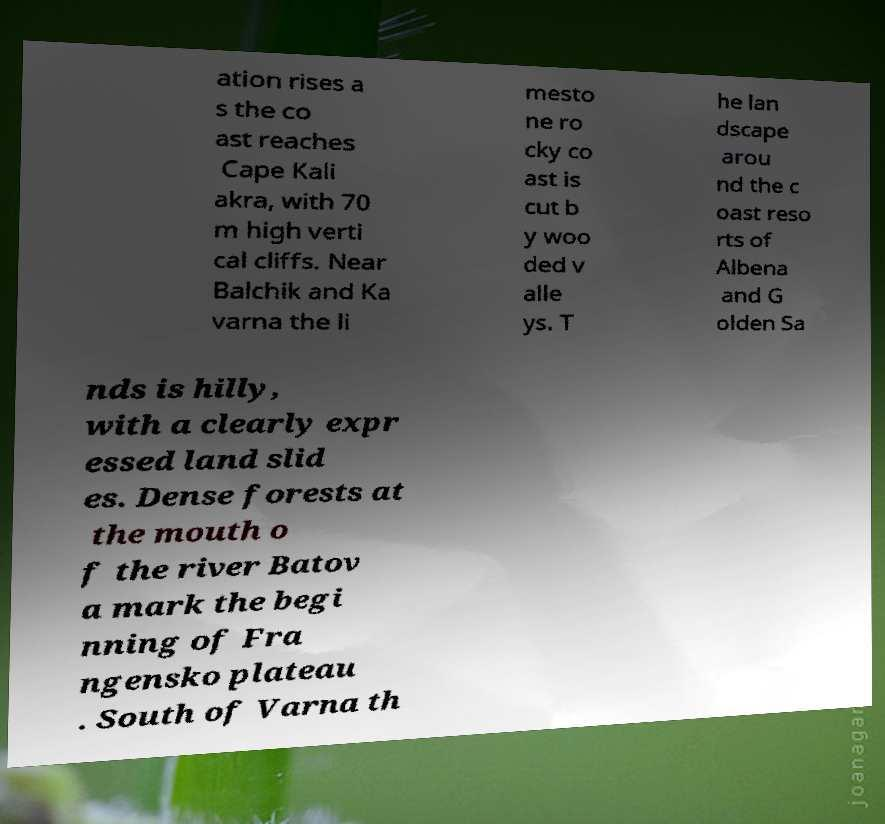Please read and relay the text visible in this image. What does it say? ation rises a s the co ast reaches Cape Kali akra, with 70 m high verti cal cliffs. Near Balchik and Ka varna the li mesto ne ro cky co ast is cut b y woo ded v alle ys. T he lan dscape arou nd the c oast reso rts of Albena and G olden Sa nds is hilly, with a clearly expr essed land slid es. Dense forests at the mouth o f the river Batov a mark the begi nning of Fra ngensko plateau . South of Varna th 